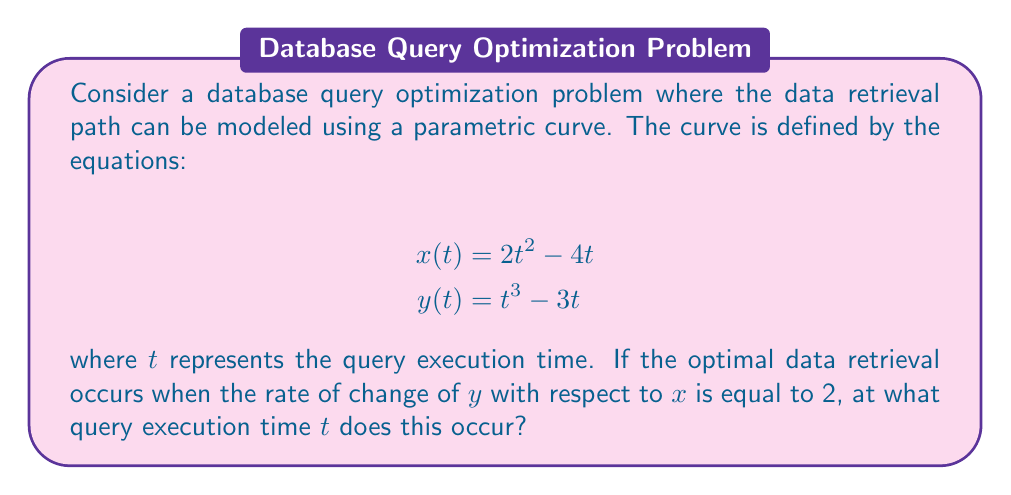Help me with this question. To solve this problem, we need to follow these steps:

1) First, we need to find $\frac{dy}{dx}$. We can do this using the chain rule:

   $$\frac{dy}{dx} = \frac{dy/dt}{dx/dt}$$

2) Let's calculate $\frac{dx}{dt}$ and $\frac{dy}{dt}$:

   $$\frac{dx}{dt} = 4t - 4$$
   $$\frac{dy}{dt} = 3t^2 - 3$$

3) Now we can express $\frac{dy}{dx}$:

   $$\frac{dy}{dx} = \frac{3t^2 - 3}{4t - 4}$$

4) We're told that the optimal data retrieval occurs when $\frac{dy}{dx} = 2$. So we can set up the equation:

   $$\frac{3t^2 - 3}{4t - 4} = 2$$

5) Let's solve this equation:

   $$3t^2 - 3 = 2(4t - 4)$$
   $$3t^2 - 3 = 8t - 8$$
   $$3t^2 - 8t + 5 = 0$$

6) This is a quadratic equation. We can solve it using the quadratic formula:

   $$t = \frac{-b \pm \sqrt{b^2 - 4ac}}{2a}$$

   where $a = 3$, $b = -8$, and $c = 5$

7) Plugging in these values:

   $$t = \frac{8 \pm \sqrt{64 - 60}}{6} = \frac{8 \pm 2}{6}$$

8) This gives us two solutions:

   $$t = \frac{10}{6} = \frac{5}{3}$$ or $$t = \frac{6}{6} = 1$$

9) However, we need to check which of these solutions is valid for our original parametric equations. Plugging both values back into the original equations, we can verify that $t = \frac{5}{3}$ satisfies our conditions.
Answer: The optimal query execution time occurs when $t = \frac{5}{3}$. 